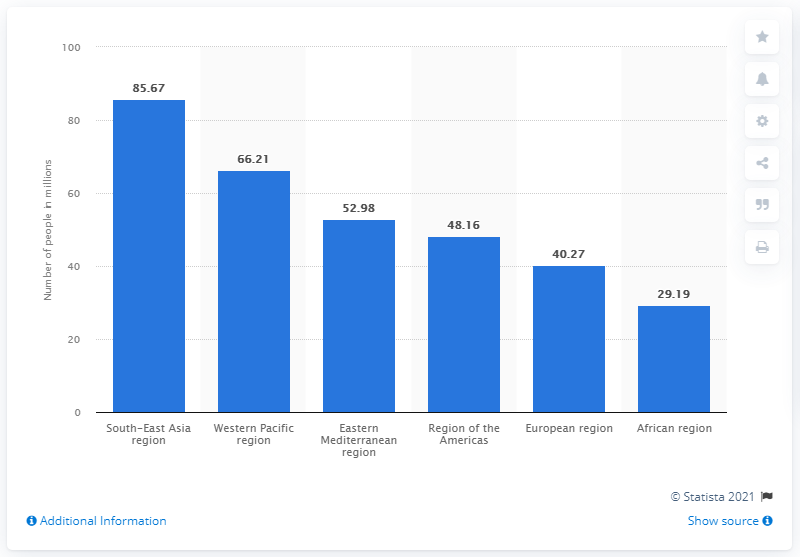Indicate a few pertinent items in this graphic. In 2015, it is estimated that approximately 85.67% of the population in the South-East Asia region lived with depression. 